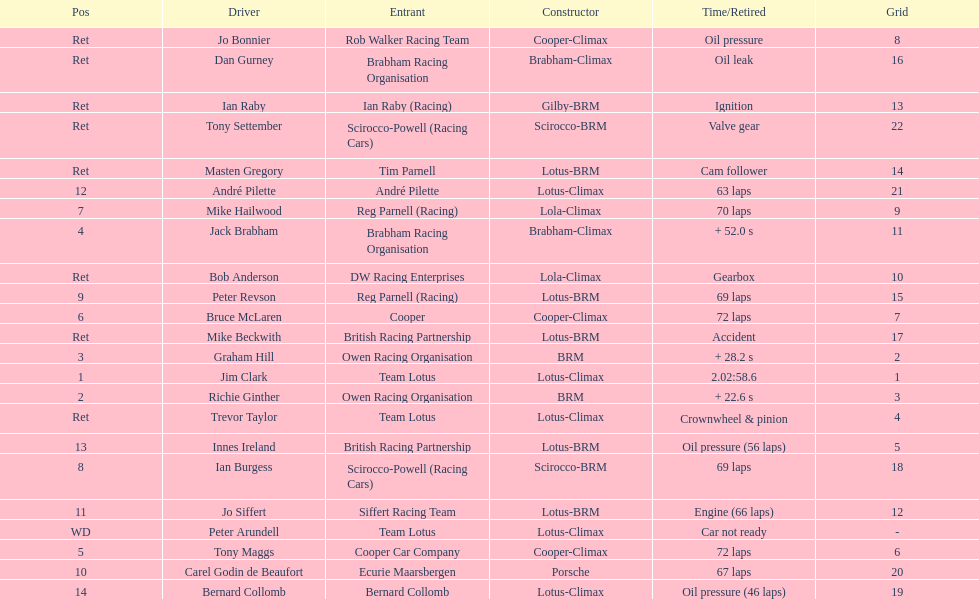What was the same problem that bernard collomb had as innes ireland? Oil pressure. 